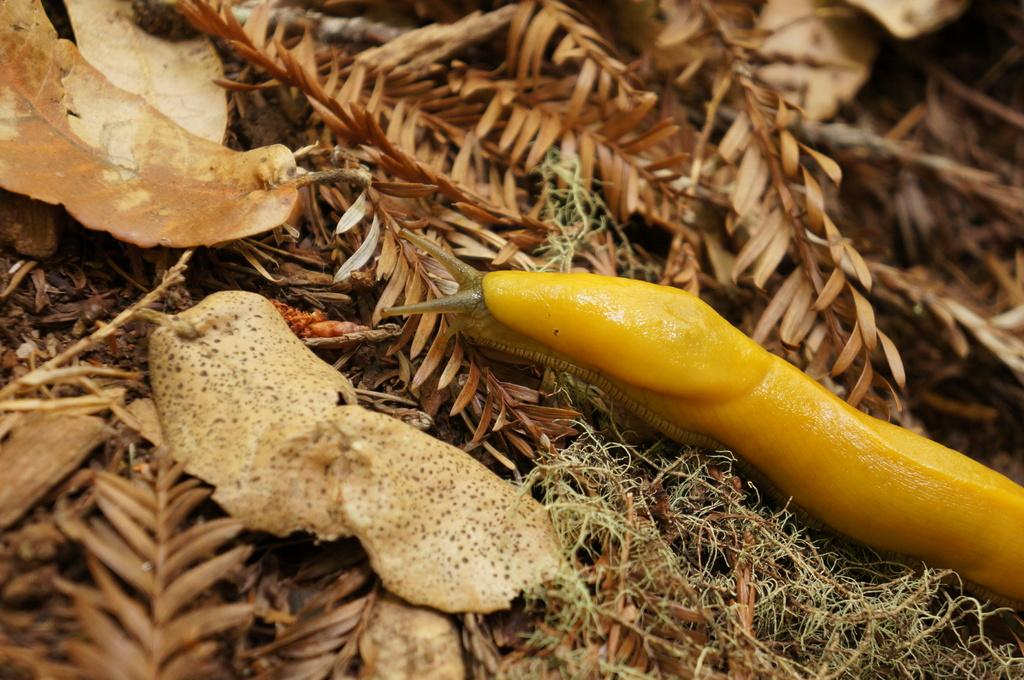What type of natural material can be seen in the image? There are dry leaves in the image. What living organism is present in the image? There is an insect in the image. What colors can be observed on the insect? The insect is brown and yellow in color. What type of town is visible in the image? There is no town present in the image; it features dry leaves and an insect. What kind of system is being used by the insect to communicate with other insects? There is no information about the insect's communication system in the image. 